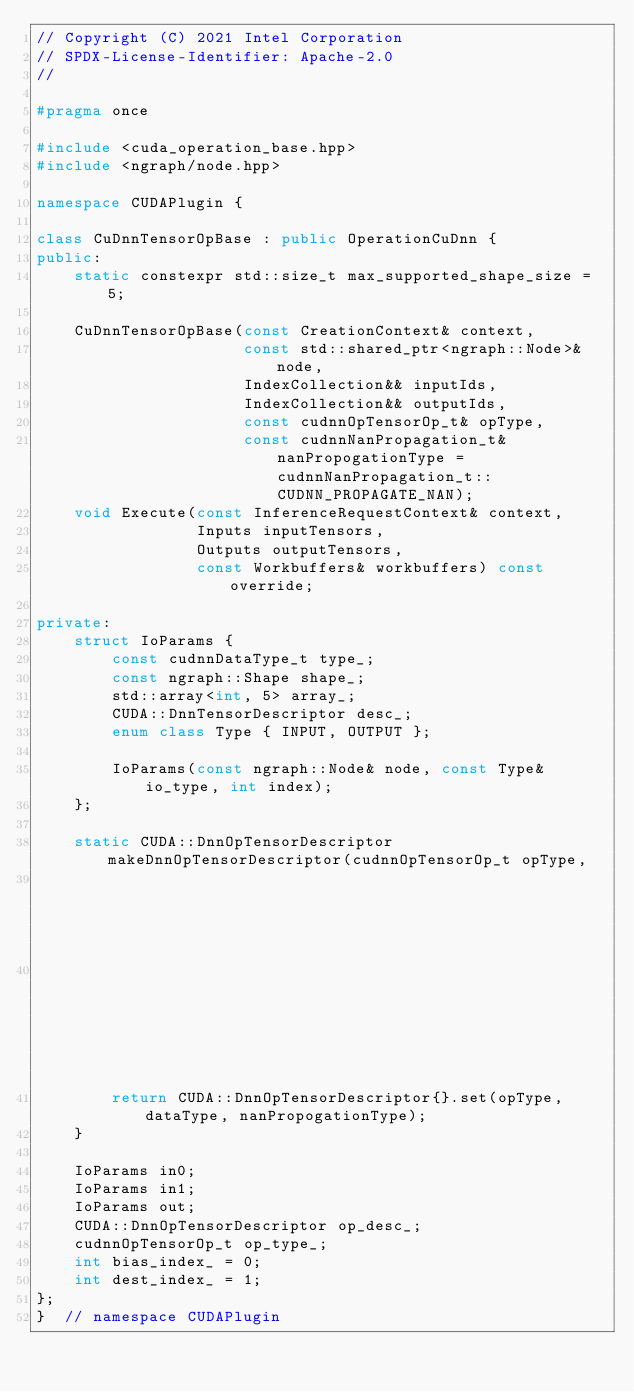<code> <loc_0><loc_0><loc_500><loc_500><_C++_>// Copyright (C) 2021 Intel Corporation
// SPDX-License-Identifier: Apache-2.0
//

#pragma once

#include <cuda_operation_base.hpp>
#include <ngraph/node.hpp>

namespace CUDAPlugin {

class CuDnnTensorOpBase : public OperationCuDnn {
public:
    static constexpr std::size_t max_supported_shape_size = 5;

    CuDnnTensorOpBase(const CreationContext& context,
                      const std::shared_ptr<ngraph::Node>& node,
                      IndexCollection&& inputIds,
                      IndexCollection&& outputIds,
                      const cudnnOpTensorOp_t& opType,
                      const cudnnNanPropagation_t& nanPropogationType = cudnnNanPropagation_t::CUDNN_PROPAGATE_NAN);
    void Execute(const InferenceRequestContext& context,
                 Inputs inputTensors,
                 Outputs outputTensors,
                 const Workbuffers& workbuffers) const override;

private:
    struct IoParams {
        const cudnnDataType_t type_;
        const ngraph::Shape shape_;
        std::array<int, 5> array_;
        CUDA::DnnTensorDescriptor desc_;
        enum class Type { INPUT, OUTPUT };

        IoParams(const ngraph::Node& node, const Type& io_type, int index);
    };

    static CUDA::DnnOpTensorDescriptor makeDnnOpTensorDescriptor(cudnnOpTensorOp_t opType,
                                                                 cudnnDataType_t dataType,
                                                                 cudnnNanPropagation_t nanPropogationType) {
        return CUDA::DnnOpTensorDescriptor{}.set(opType, dataType, nanPropogationType);
    }

    IoParams in0;
    IoParams in1;
    IoParams out;
    CUDA::DnnOpTensorDescriptor op_desc_;
    cudnnOpTensorOp_t op_type_;
    int bias_index_ = 0;
    int dest_index_ = 1;
};
}  // namespace CUDAPlugin
</code> 